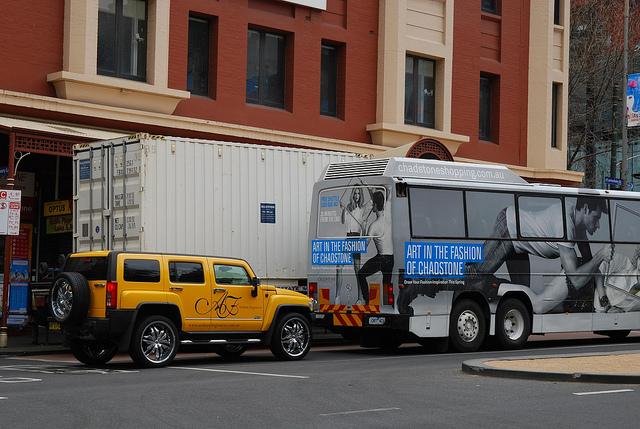What is yellow in the picture?
Short answer required. Hummer. Is there a plow attached to the truck?
Give a very brief answer. No. What is the man doing on the side of the bus?
Concise answer only. Crawling. Is this a dump?
Short answer required. No. How many people are in the yellow cart?
Quick response, please. 1. Is there a big container next to the bus?
Write a very short answer. Yes. Where is the bus?
Short answer required. On street. Is this picture in color?
Keep it brief. Yes. What does the bus say?
Be succinct. Art in fashion of chadstone. 